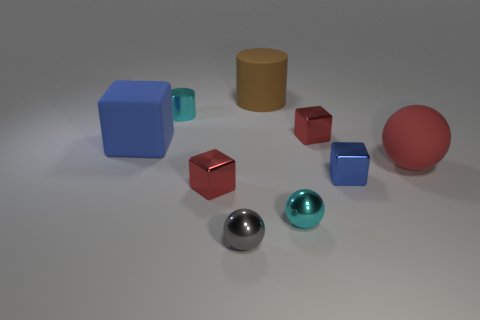Subtract 1 blocks. How many blocks are left? 3 Add 1 big cylinders. How many objects exist? 10 Subtract all cubes. How many objects are left? 5 Add 8 small yellow matte cubes. How many small yellow matte cubes exist? 8 Subtract 1 cyan spheres. How many objects are left? 8 Subtract all large matte blocks. Subtract all blue rubber things. How many objects are left? 7 Add 7 small gray metallic objects. How many small gray metallic objects are left? 8 